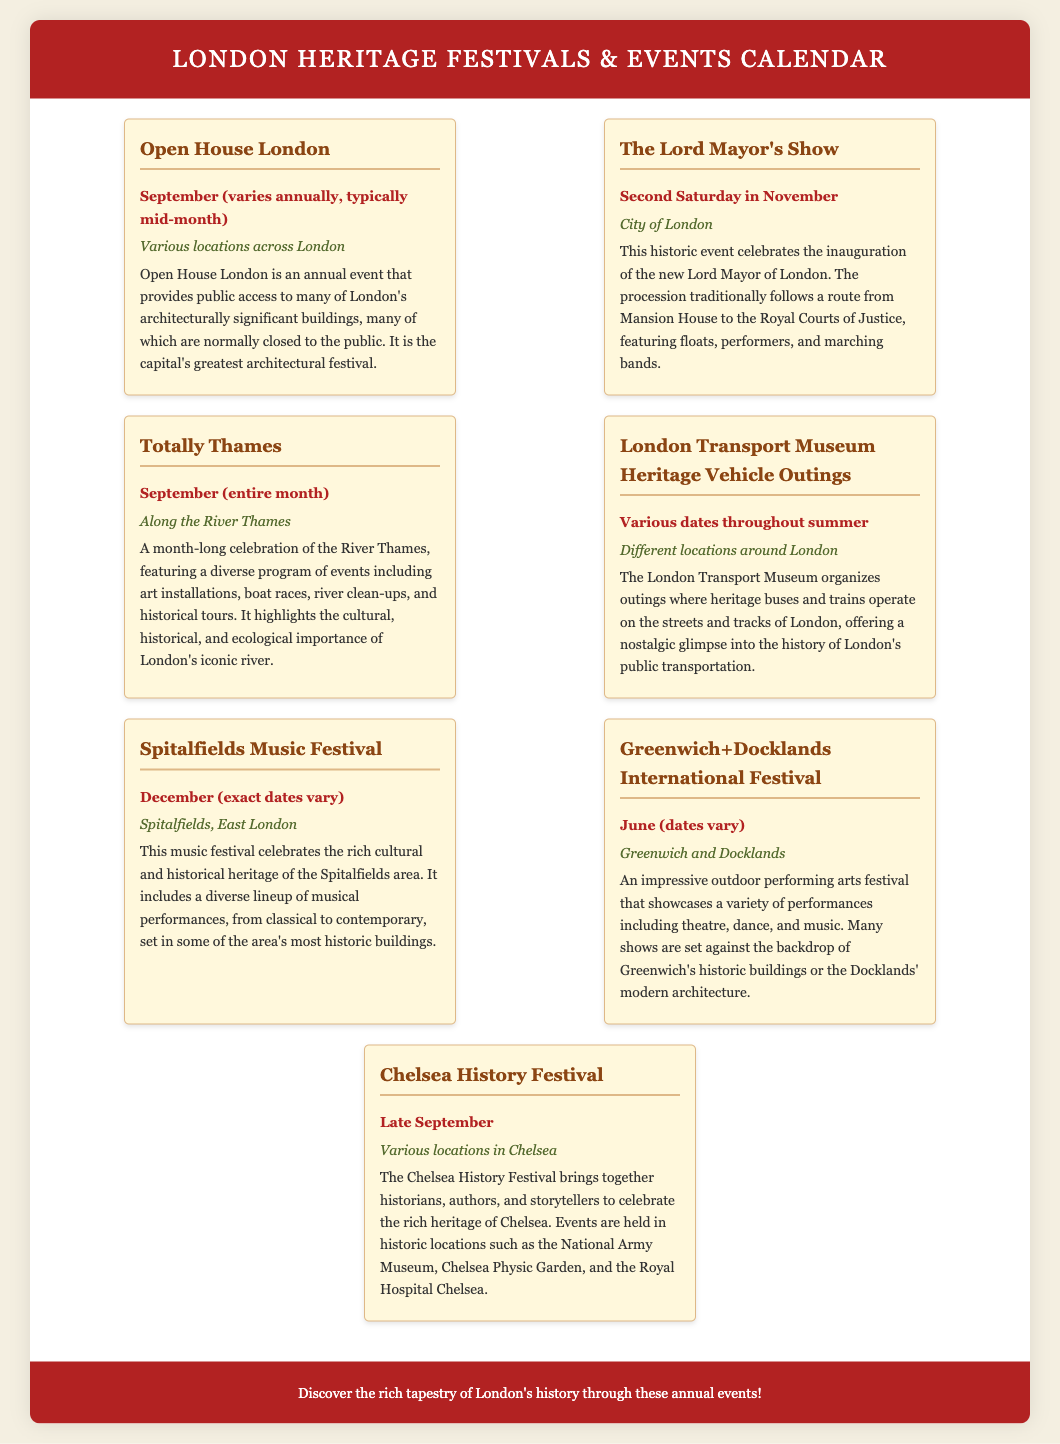what is the name of the event that allows access to architecturally significant buildings? Open House London provides public access to many architecturally significant buildings, which are normally closed to the public.
Answer: Open House London when is The Lord Mayor's Show held? The Lord Mayor's Show occurs on the second Saturday in November.
Answer: Second Saturday in November where does the Totally Thames event take place? Totally Thames is celebrated along the River Thames.
Answer: Along the River Thames which month does the Spitalfields Music Festival occur? The Spitalfields Music Festival is held in December, but the exact dates vary.
Answer: December what type of performances are featured at the Greenwich+Docklands International Festival? The festival showcases a variety of performances including theatre, dance, and music.
Answer: Theatre, dance, and music what is a characteristic feature of the Chelsea History Festival? The Chelsea History Festival celebrates the rich heritage of Chelsea with events in historic locations.
Answer: Historic locations how many events are listed in the document? Counting all the events mentioned, there are seven unique heritage festivals and events listed.
Answer: Seven what is the purpose of the London Transport Museum Heritage Vehicle Outings? The outings offer a nostalgic glimpse into the history of London's public transportation using heritage buses and trains.
Answer: Nostalgic glimpse what month does the Open House London festival typically take place? Open House London typically takes place in September, mid-month.
Answer: September 